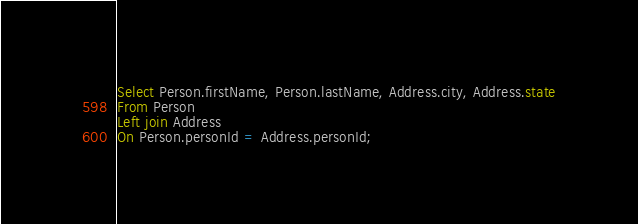<code> <loc_0><loc_0><loc_500><loc_500><_SQL_>Select Person.firstName, Person.lastName, Address.city, Address.state
From Person
Left join Address
On Person.personId = Address.personId;
</code> 